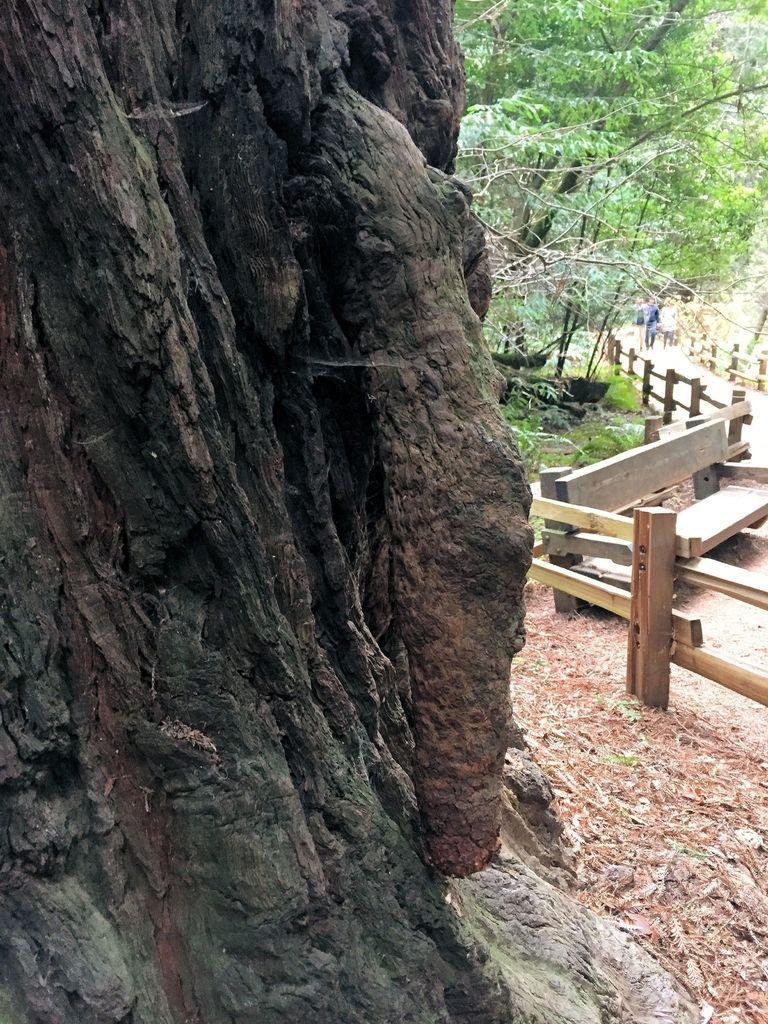Describe this image in one or two sentences. In this picture we can see a tree trunk, bench on the ground, fences, trees, grass and some people on a path. 